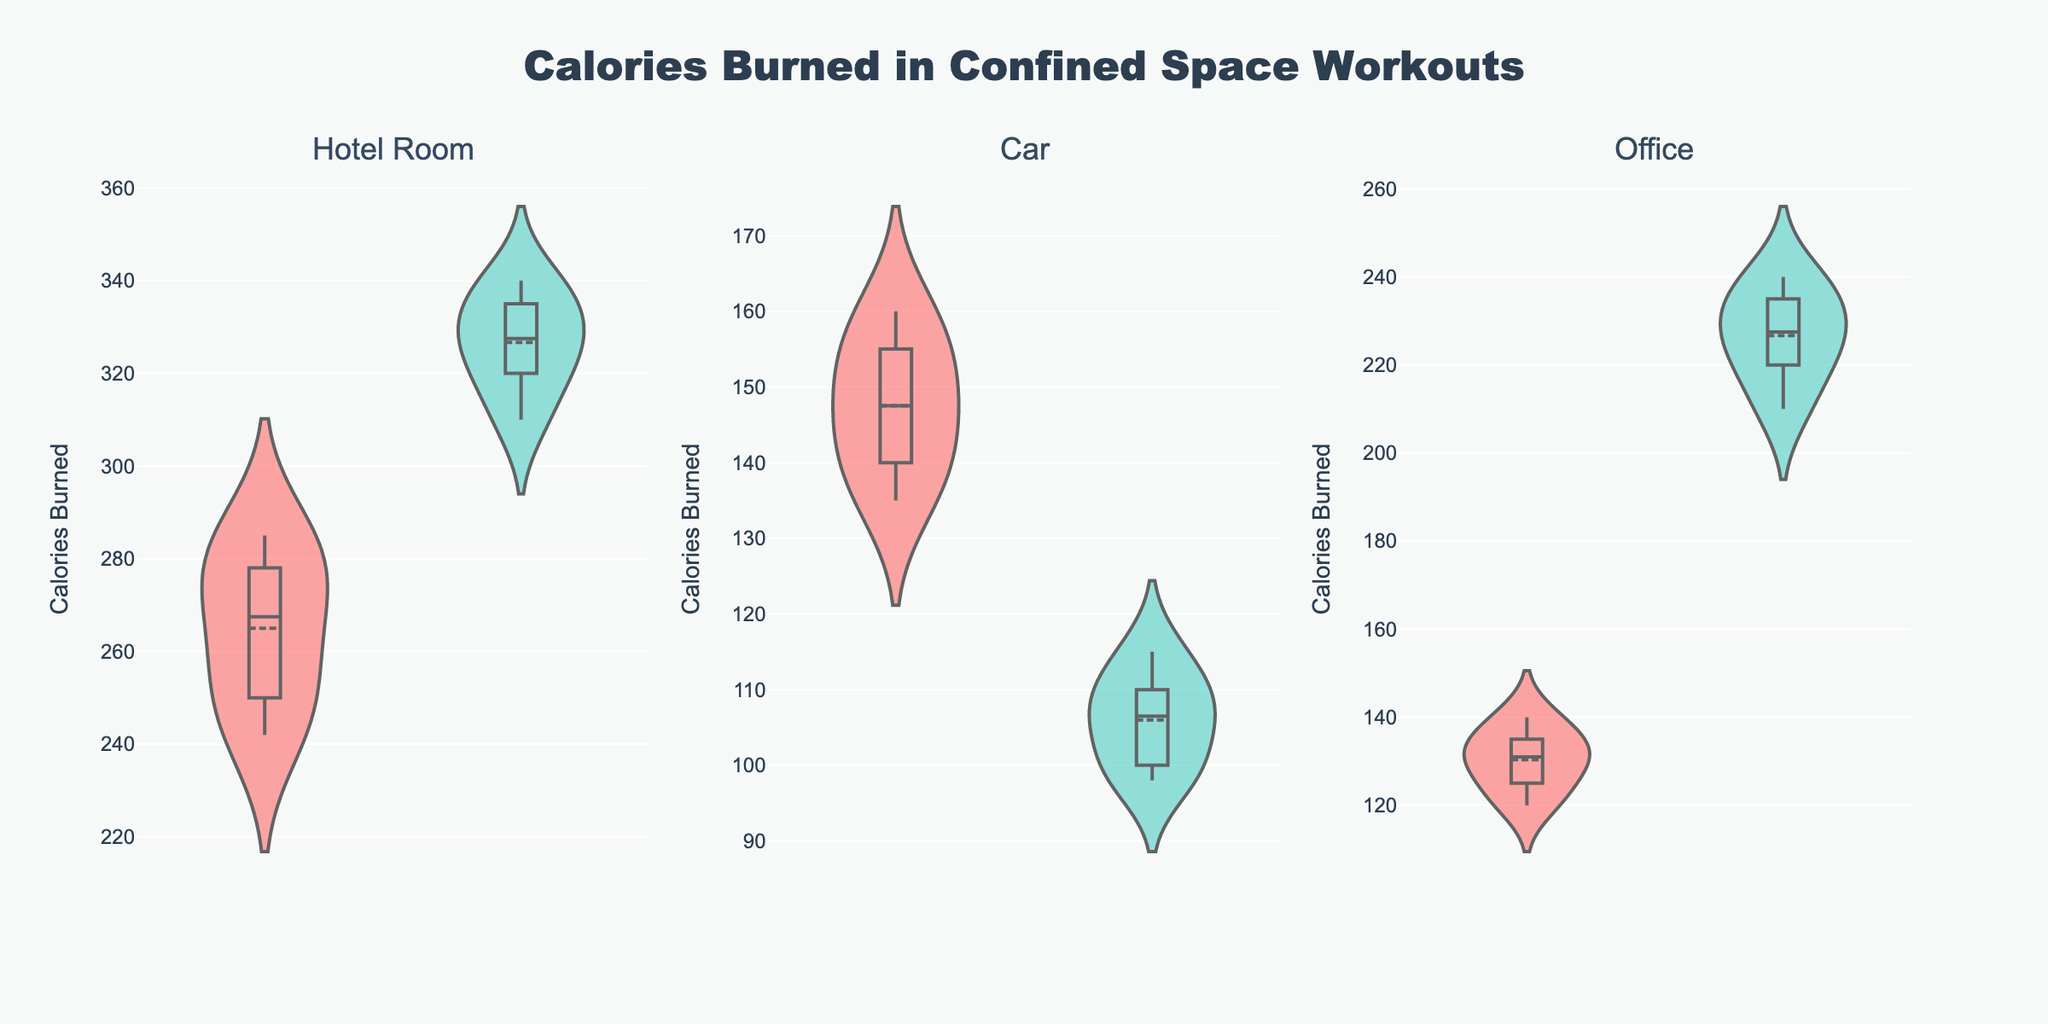What is the title of the figure? The title can be seen at the top of the figure.
Answer: Calories Burned in Confined Space Workouts Which workout type in the hotel room burns the most calories on average? Compare the average calories burned for 'Hotel Room Bodyweight Workout' and 'Hotel Room HIIT Workout' by looking at the mean lines in the violin plots.
Answer: Hotel Room HIIT Workout How many types of workouts are there for each confined space? Count the number of distinct workout types shown under each confined space category, as indicated by the subplots.
Answer: 2 Which confined space has the highest variation in calories burned? The variation in calories burned can be identified by the spread of the violin plots. The more spread out the plot, the higher the variation.
Answer: Hotel Room What's the median value for calories burned in the Office Desk Yoga workout? The median value can be identified by the central horizontal line inside the violin plot for 'Office Desk Yoga'.
Answer: 130 Are there any workout types in the car that burn more calories than any workout type in a hotel room? Compare the range of calories burned in car workout types to the range in hotel room workout types.
Answer: No Which workout type in the office has the higher maximum calories burned? Look at the maximum point in the violin plots for 'Office Desk Yoga' and 'Office Chair Cardio'.
Answer: Office Chair Cardio Between the Hotel Room Bodyweight Workout and the Car Seated Abs Routine, which has a wider range of calories burned? Compare the overall span (from minimum to maximum calories burned) of the violin plots for 'Hotel Room Bodyweight Workout' and 'Car Seated Abs Routine'.
Answer: Hotel Room Bodyweight Workout What is the color of the violin plot for the Car Isometric Exercises? Identify the color used for the violin plot of 'Car Isometric Exercises' in the subplot for Car workouts.
Answer: Teal Which workout type in the hotel room shows less variability in calories burned? Observe the spread and density of calories burned in the violin plots for 'Hotel Room Bodyweight Workout' and 'Hotel Room HIIT Workout'. Less spread indicates less variability.
Answer: Hotel Room HIIT Workout 